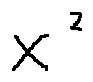Convert formula to latex. <formula><loc_0><loc_0><loc_500><loc_500>x ^ { 2 }</formula> 